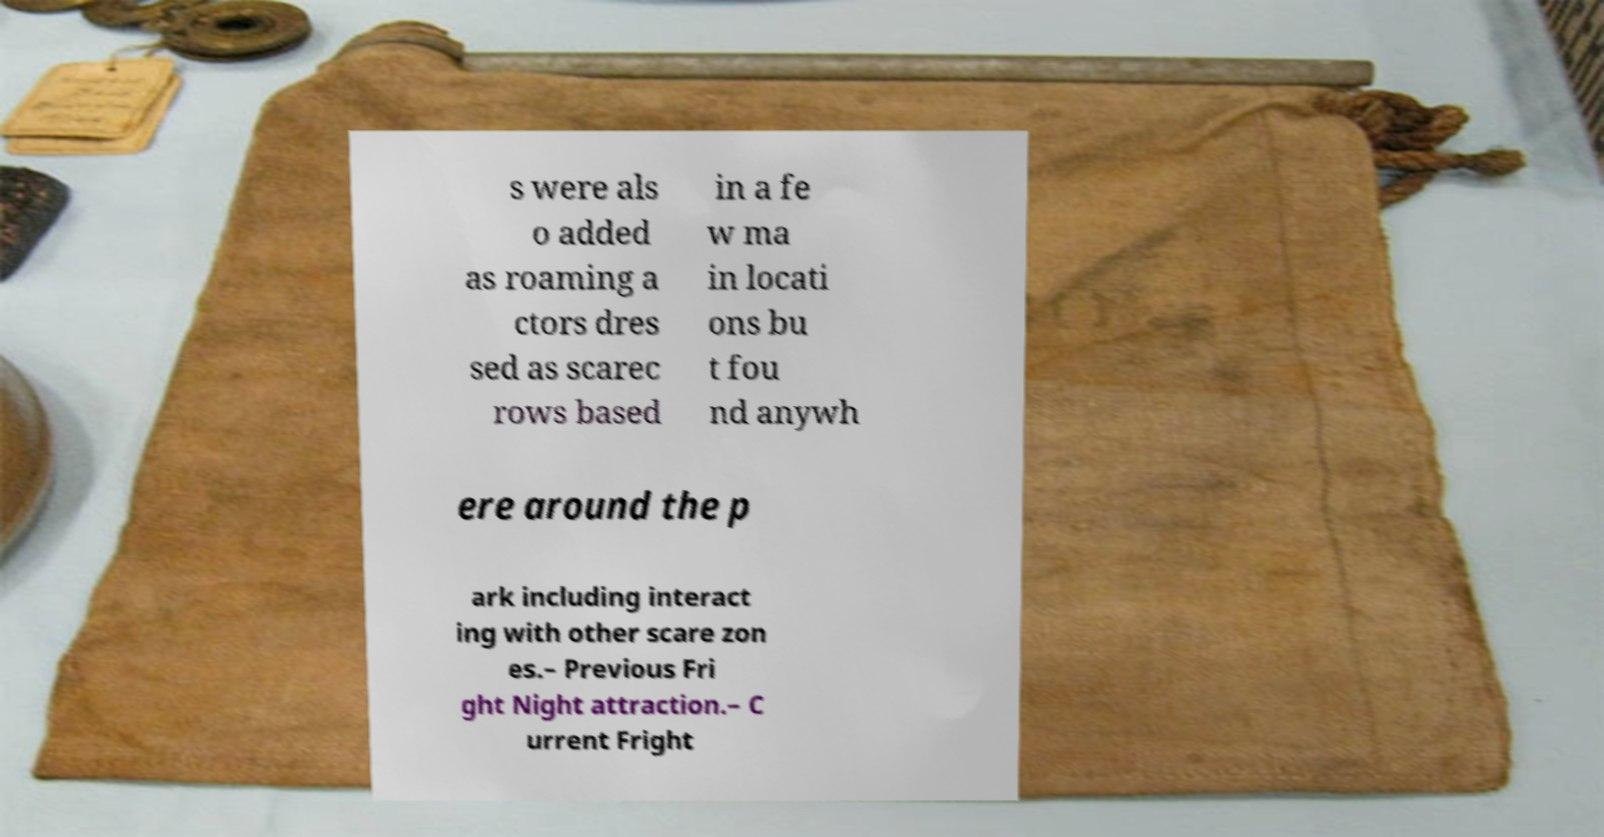Could you assist in decoding the text presented in this image and type it out clearly? s were als o added as roaming a ctors dres sed as scarec rows based in a fe w ma in locati ons bu t fou nd anywh ere around the p ark including interact ing with other scare zon es.– Previous Fri ght Night attraction.– C urrent Fright 